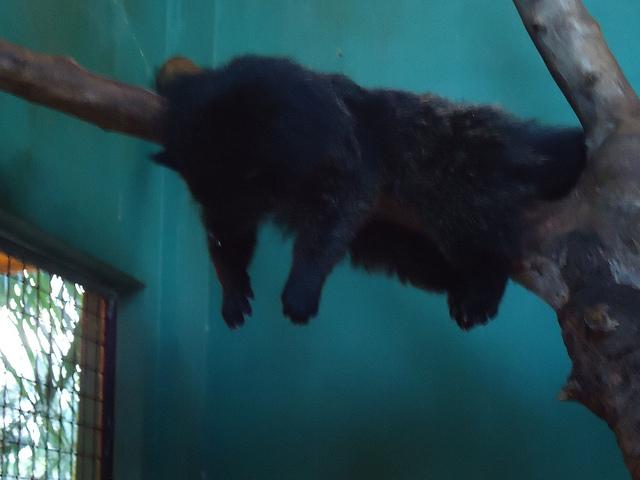What kind of tree is the bear in?
Write a very short answer. Oak. Is the cat looking at something?
Short answer required. No. Is the animal alive?
Keep it brief. Yes. What is this animal doing?
Give a very brief answer. Sleeping. What color is the bear?
Short answer required. Black. Is this a habitat?
Short answer required. Yes. What is stuck?
Keep it brief. Cat. What color is the animal?
Be succinct. Black. Are the animals behind a fence?
Quick response, please. Yes. Where is the bear?
Quick response, please. Tree. What are the bears hanging on?
Give a very brief answer. Tree. Is the animal in the tree real?
Be succinct. Yes. Is this in a forest?
Be succinct. No. What color is this animal?
Short answer required. Black. Is it light or dark?
Write a very short answer. Dark. What color is the cat?
Answer briefly. Black. 